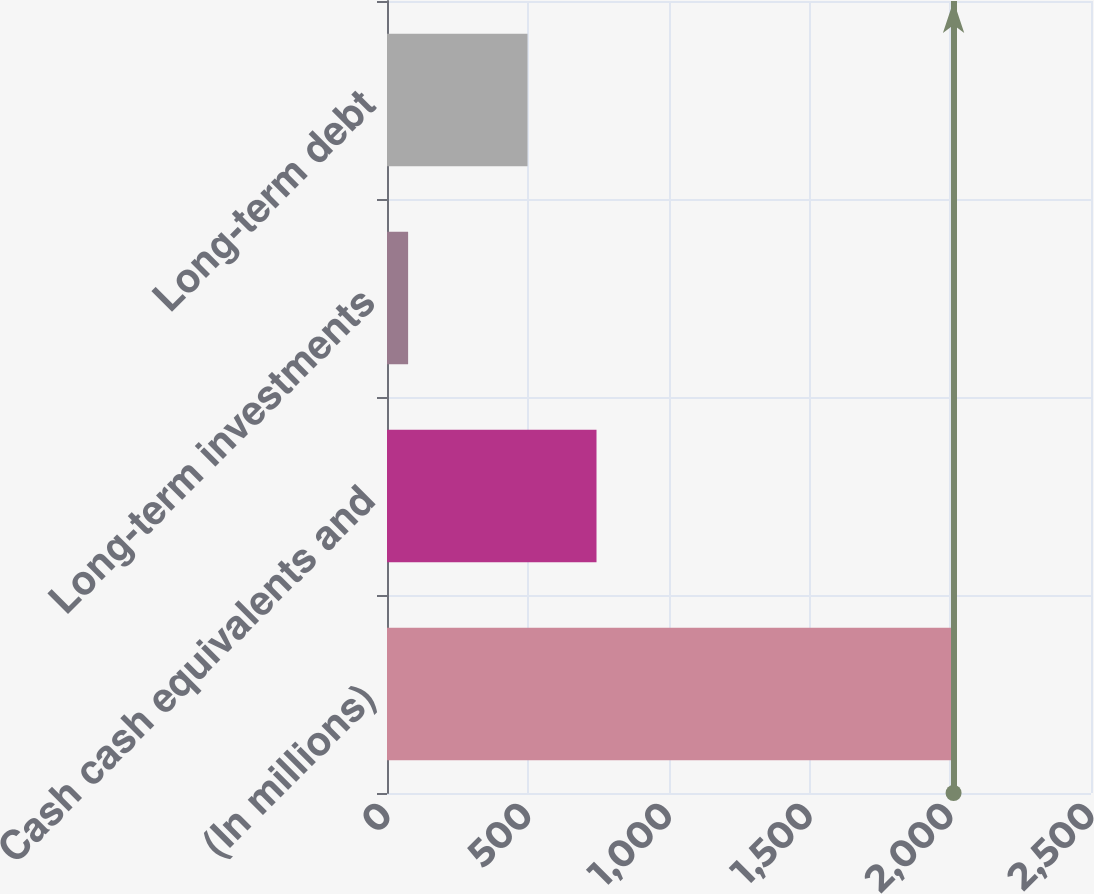Convert chart to OTSL. <chart><loc_0><loc_0><loc_500><loc_500><bar_chart><fcel>(In millions)<fcel>Cash cash equivalents and<fcel>Long-term investments<fcel>Long-term debt<nl><fcel>2012<fcel>744<fcel>75<fcel>499<nl></chart> 